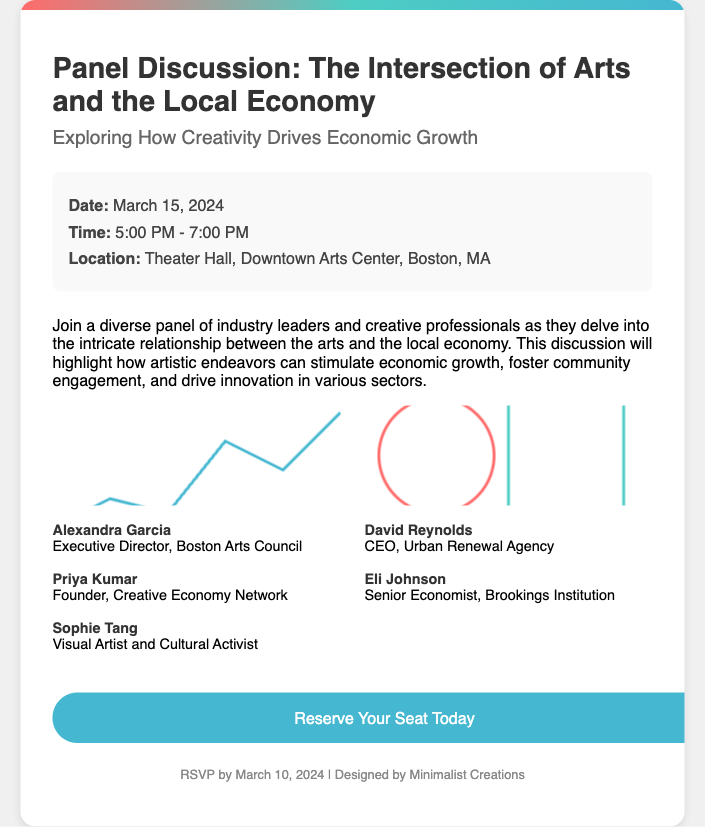What is the date of the panel discussion? The date can be found in the details section of the RSVP card.
Answer: March 15, 2024 What time does the panel discussion begin? The time is specified in the details section of the RSVP card.
Answer: 5:00 PM Where is the event taking place? The location is mentioned in the details section of the RSVP card.
Answer: Theater Hall, Downtown Arts Center, Boston, MA Who is the Executive Director of the Boston Arts Council? This information is provided in the panelists section regarding their roles.
Answer: Alexandra Garcia How many panelists are listed in the document? The document includes a specific number of individuals introduced as panelists.
Answer: Five What is the main theme of the panel discussion? The theme is stated in the title and introductory paragraph of the RSVP card.
Answer: The Intersection of Arts and the Local Economy What is the RSVP deadline? The RSVP deadline is specified in the footer section of the card.
Answer: March 10, 2024 What should attendees click to reserve their seat? The action call for reservations is presented as a button link within the card.
Answer: Reserve Your Seat Today Who is the Senior Economist on the panel? This is outlined in the panelists section alongside their roles.
Answer: Eli Johnson 